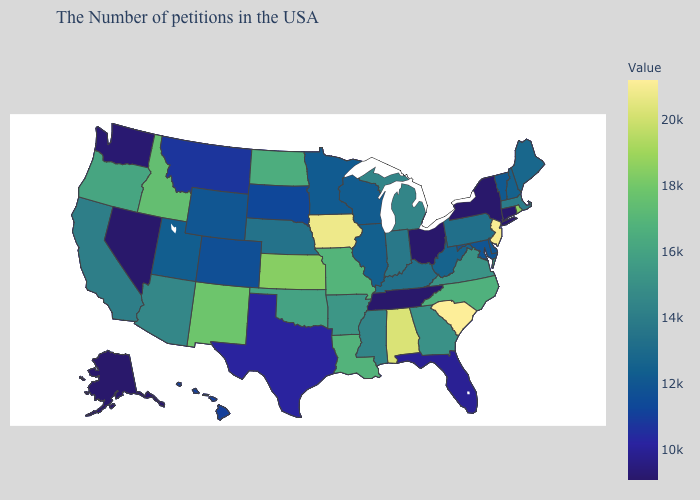Which states hav the highest value in the Northeast?
Give a very brief answer. New Jersey. Which states hav the highest value in the South?
Answer briefly. South Carolina. 